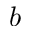<formula> <loc_0><loc_0><loc_500><loc_500>b</formula> 